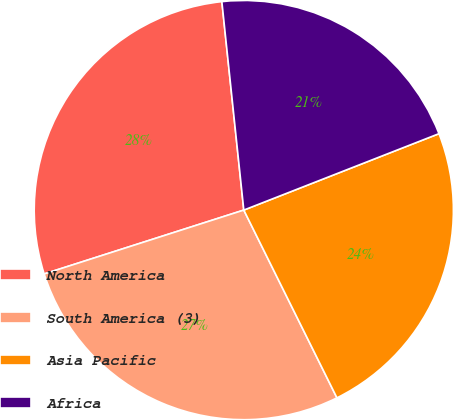<chart> <loc_0><loc_0><loc_500><loc_500><pie_chart><fcel>North America<fcel>South America (3)<fcel>Asia Pacific<fcel>Africa<nl><fcel>28.26%<fcel>27.4%<fcel>23.61%<fcel>20.73%<nl></chart> 